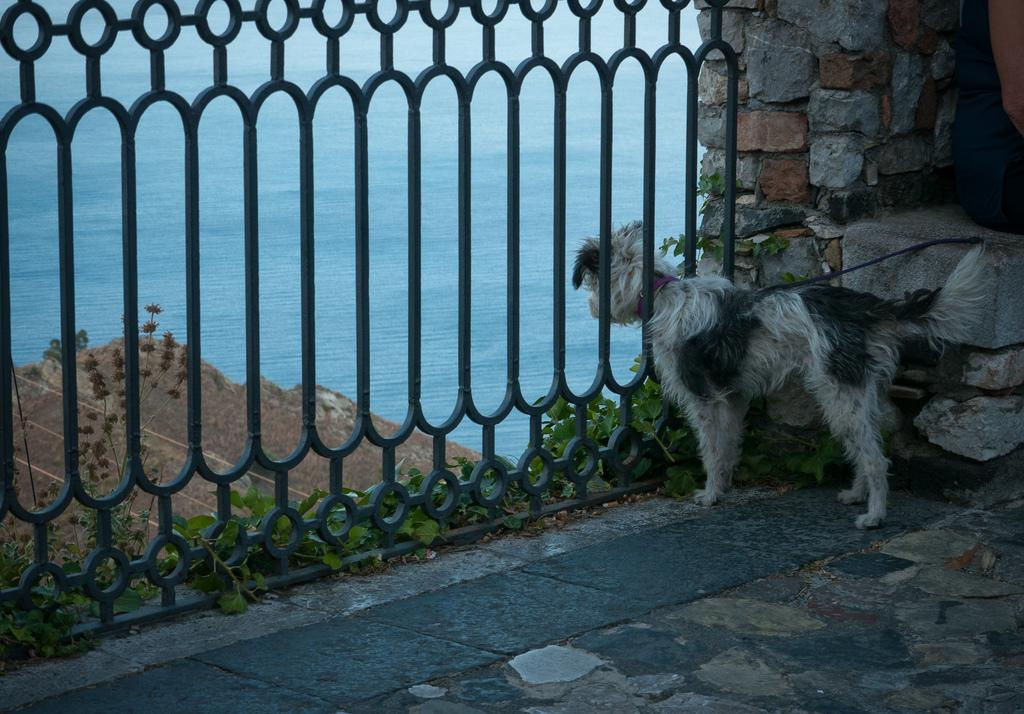What type of animal is present in the image? There is a dog in the image. What other elements can be seen in the image? There are plants, a fence, a wall, and a person visible in the image. What can be seen in the background of the image? There is water visible in the background of the image. What type of crown is the dog wearing in the image? There is no crown present in the image; the dog is not wearing any accessories. 